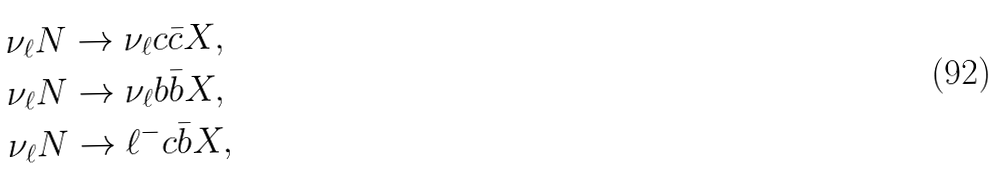Convert formula to latex. <formula><loc_0><loc_0><loc_500><loc_500>\nu _ { \ell } N & \rightarrow \nu _ { \ell } c \bar { c } X , \\ \nu _ { \ell } N & \rightarrow \nu _ { \ell } b \bar { b } X , \\ \nu _ { \ell } N & \rightarrow \ell ^ { - } c \bar { b } X ,</formula> 